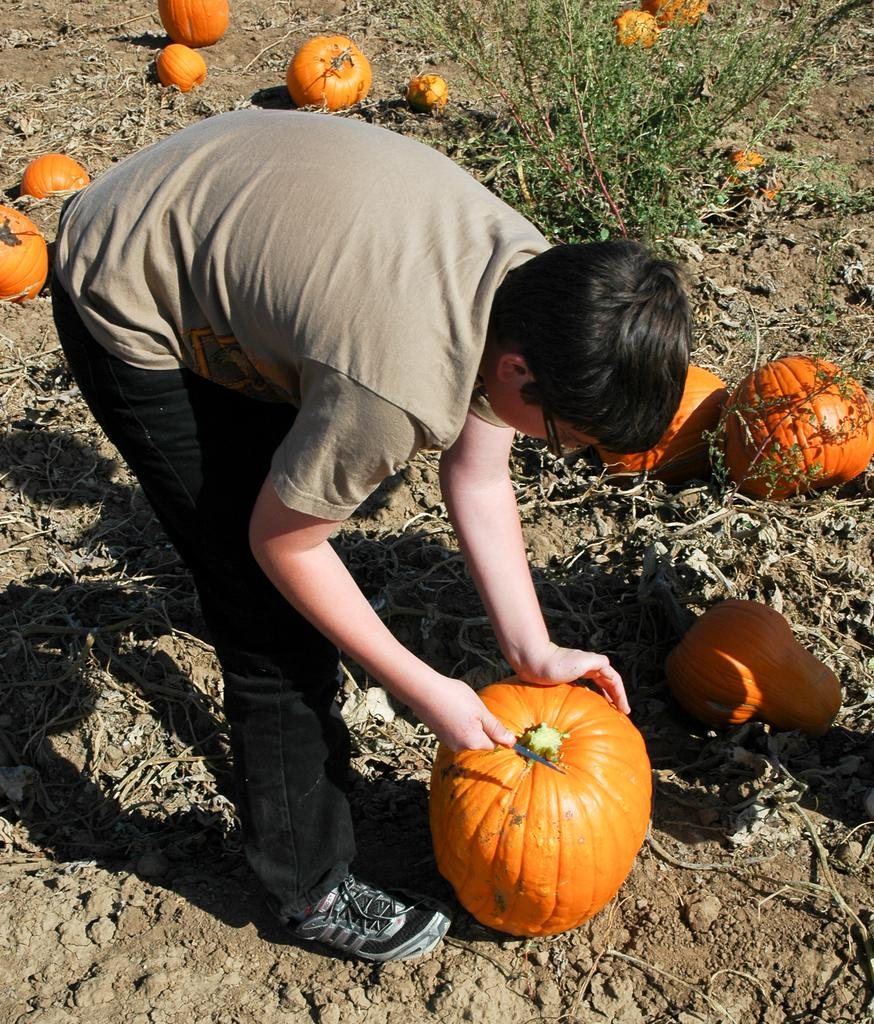What is the person in the image doing? The person is standing in the image and holding a knife and a pumpkin. What objects is the person holding in the image? The person is holding a knife and a pumpkin. What can be seen in the background of the image? There are pumpkins and a plant in the background of the image. What type of arch can be seen in the background of the image? There is no arch present in the image; it only features a person holding a knife and a pumpkin, along with pumpkins and a plant in the background. 